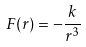<formula> <loc_0><loc_0><loc_500><loc_500>F ( r ) = - \frac { k } { r ^ { 3 } }</formula> 